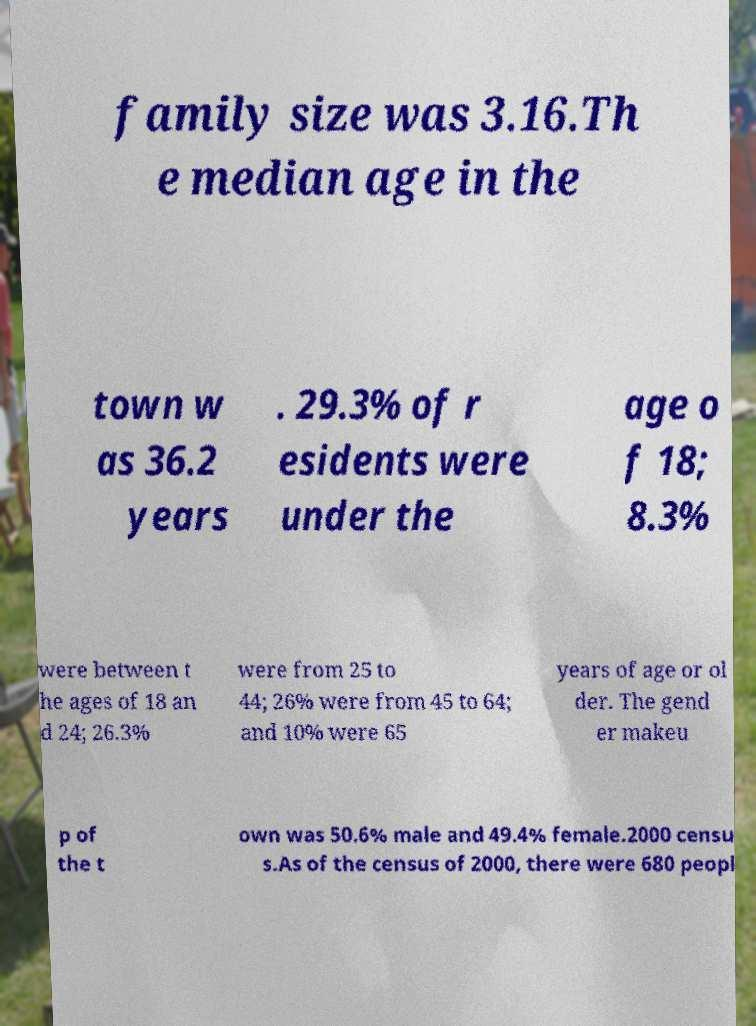Could you assist in decoding the text presented in this image and type it out clearly? family size was 3.16.Th e median age in the town w as 36.2 years . 29.3% of r esidents were under the age o f 18; 8.3% were between t he ages of 18 an d 24; 26.3% were from 25 to 44; 26% were from 45 to 64; and 10% were 65 years of age or ol der. The gend er makeu p of the t own was 50.6% male and 49.4% female.2000 censu s.As of the census of 2000, there were 680 peopl 